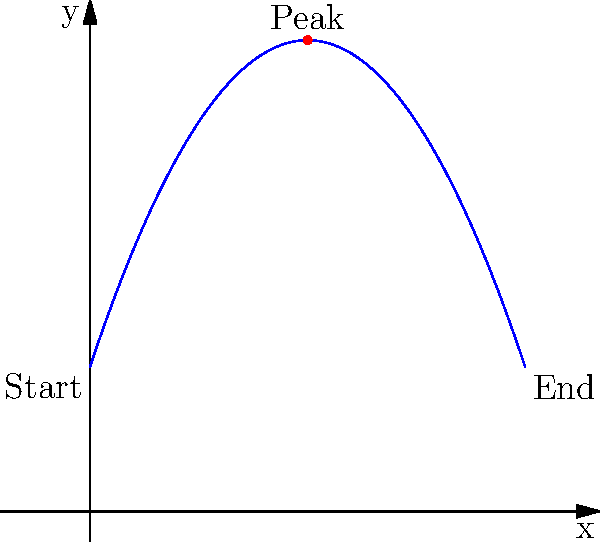During a performance, you execute a grand jeté (a long horizontal jump) that follows a parabolic path. The trajectory of your jump can be modeled by the function $f(x) = -0.5x^2 + 3x + 2$, where $x$ represents the horizontal distance (in meters) and $f(x)$ represents the height (in meters). What is the maximum height you reach during this jump? To find the maximum height of the jump, we need to follow these steps:

1) The maximum height occurs at the vertex of the parabola.

2) For a quadratic function in the form $f(x) = ax^2 + bx + c$, the x-coordinate of the vertex is given by $x = -\frac{b}{2a}$.

3) In our function $f(x) = -0.5x^2 + 3x + 2$:
   $a = -0.5$
   $b = 3$
   $c = 2$

4) Calculating the x-coordinate of the vertex:
   $x = -\frac{b}{2a} = -\frac{3}{2(-0.5)} = 3$

5) To find the maximum height, we need to calculate $f(3)$:
   $f(3) = -0.5(3)^2 + 3(3) + 2$
   $= -0.5(9) + 9 + 2$
   $= -4.5 + 9 + 2$
   $= 6.5$

Therefore, the maximum height reached during the jump is 6.5 meters.
Answer: 6.5 meters 